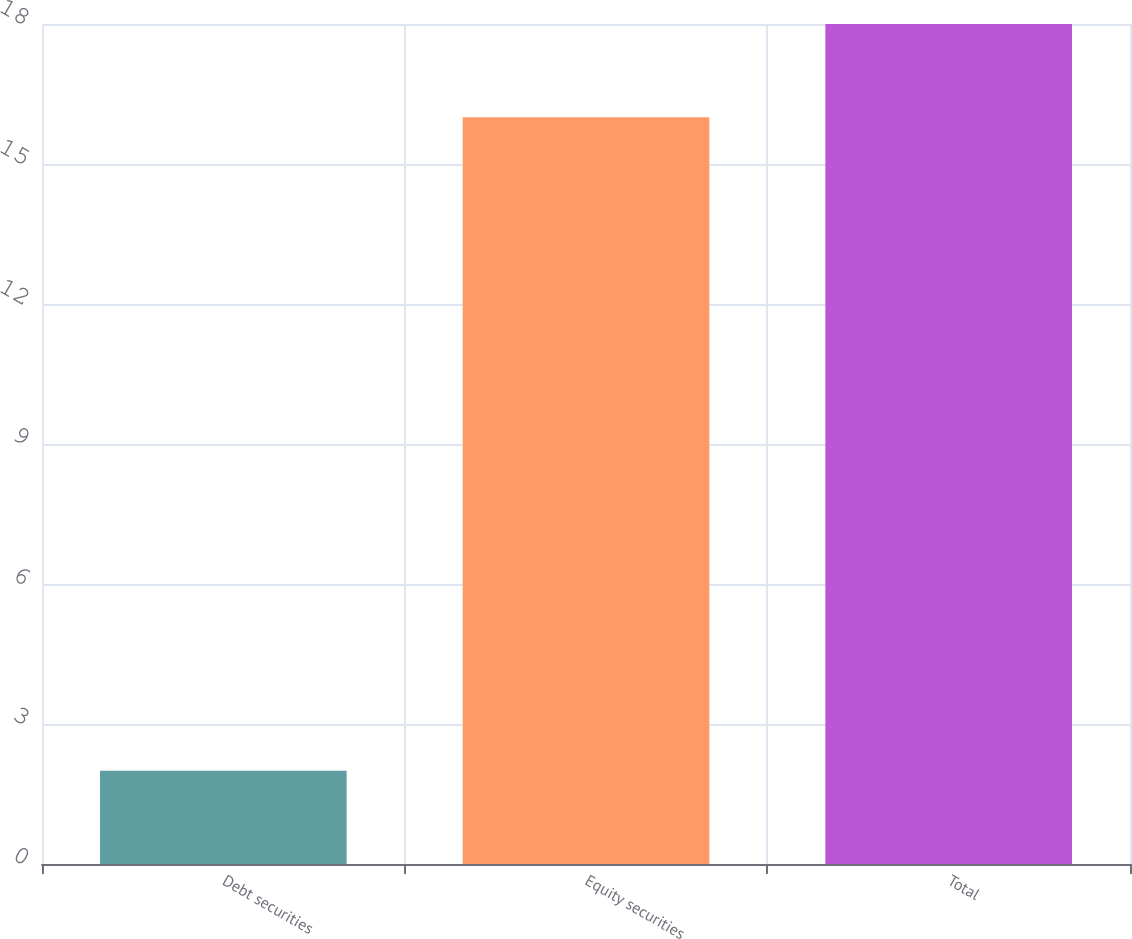<chart> <loc_0><loc_0><loc_500><loc_500><bar_chart><fcel>Debt securities<fcel>Equity securities<fcel>Total<nl><fcel>2<fcel>16<fcel>18<nl></chart> 